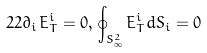Convert formula to latex. <formula><loc_0><loc_0><loc_500><loc_500>2 2 \partial _ { i } E _ { T } ^ { i } = 0 , \, \oint _ { S _ { \infty } ^ { 2 } } E _ { T } ^ { i } d S _ { i } = 0</formula> 